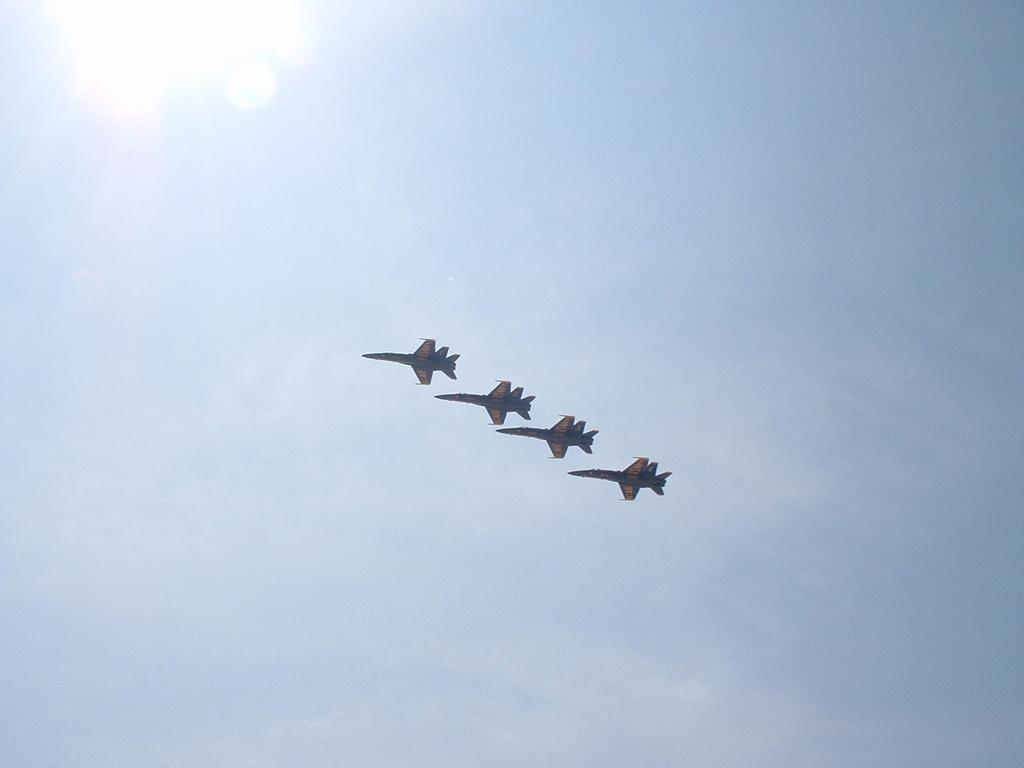How many aircraft are present in the image? There are four aircraft in the image. What are the aircraft doing in the image? The aircraft are in the air. What celestial body is visible in the image? The sun is visible in the image. What else can be seen in the image besides the aircraft? The sky is visible in the image. What type of shirt is being worn by the stew in the image? There is no stew or shirt present in the image; it features four aircraft in the air. 